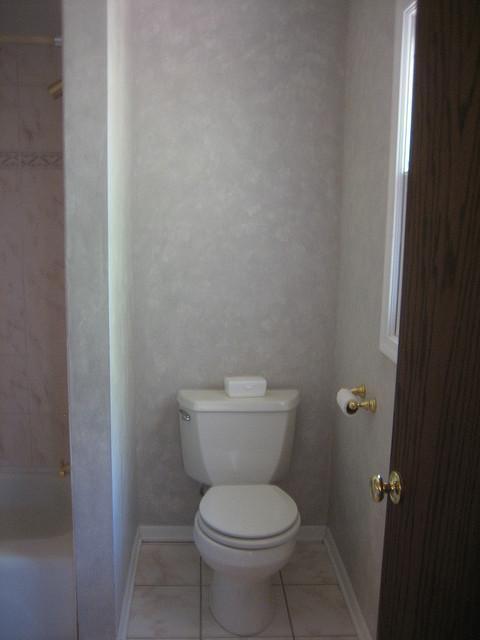How many people are actually skateboarding?
Give a very brief answer. 0. 